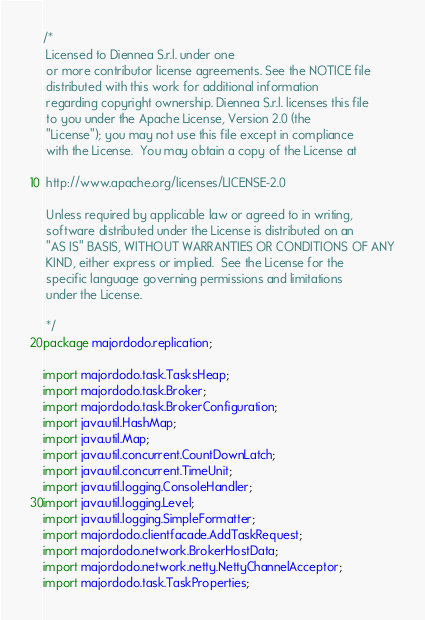<code> <loc_0><loc_0><loc_500><loc_500><_Java_>/*
 Licensed to Diennea S.r.l. under one
 or more contributor license agreements. See the NOTICE file
 distributed with this work for additional information
 regarding copyright ownership. Diennea S.r.l. licenses this file
 to you under the Apache License, Version 2.0 (the
 "License"); you may not use this file except in compliance
 with the License.  You may obtain a copy of the License at

 http://www.apache.org/licenses/LICENSE-2.0

 Unless required by applicable law or agreed to in writing,
 software distributed under the License is distributed on an
 "AS IS" BASIS, WITHOUT WARRANTIES OR CONDITIONS OF ANY
 KIND, either express or implied.  See the License for the
 specific language governing permissions and limitations
 under the License.

 */
package majordodo.replication;

import majordodo.task.TasksHeap;
import majordodo.task.Broker;
import majordodo.task.BrokerConfiguration;
import java.util.HashMap;
import java.util.Map;
import java.util.concurrent.CountDownLatch;
import java.util.concurrent.TimeUnit;
import java.util.logging.ConsoleHandler;
import java.util.logging.Level;
import java.util.logging.SimpleFormatter;
import majordodo.clientfacade.AddTaskRequest;
import majordodo.network.BrokerHostData;
import majordodo.network.netty.NettyChannelAcceptor;
import majordodo.task.TaskProperties;</code> 